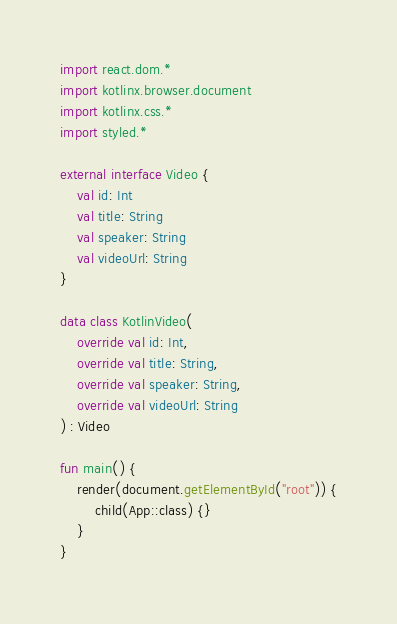<code> <loc_0><loc_0><loc_500><loc_500><_Kotlin_>import react.dom.*
import kotlinx.browser.document
import kotlinx.css.*
import styled.*

external interface Video {
    val id: Int
    val title: String
    val speaker: String
    val videoUrl: String
}

data class KotlinVideo(
    override val id: Int,
    override val title: String,
    override val speaker: String,
    override val videoUrl: String
) : Video

fun main() {
    render(document.getElementById("root")) {
        child(App::class) {}
    }
}</code> 